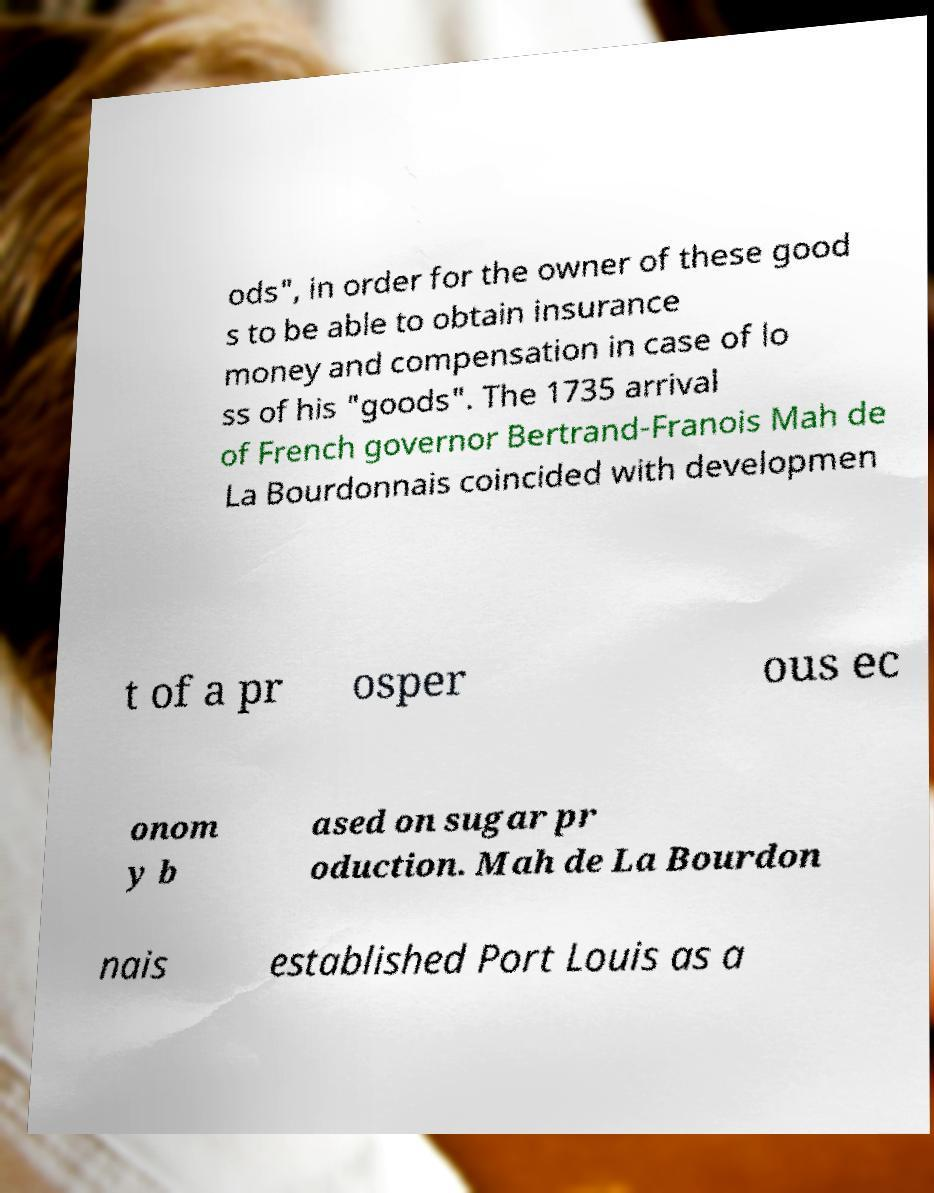Could you assist in decoding the text presented in this image and type it out clearly? ods", in order for the owner of these good s to be able to obtain insurance money and compensation in case of lo ss of his "goods". The 1735 arrival of French governor Bertrand-Franois Mah de La Bourdonnais coincided with developmen t of a pr osper ous ec onom y b ased on sugar pr oduction. Mah de La Bourdon nais established Port Louis as a 